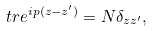<formula> <loc_0><loc_0><loc_500><loc_500>\ t r e ^ { i p ( z - z ^ { \prime } ) } = N \delta _ { z z ^ { \prime } } ,</formula> 